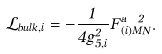Convert formula to latex. <formula><loc_0><loc_0><loc_500><loc_500>\mathcal { L } _ { b u l k , i } = - \frac { 1 } { 4 g _ { 5 , i } ^ { 2 } } F _ { ( i ) M N } ^ { a \ 2 } .</formula> 